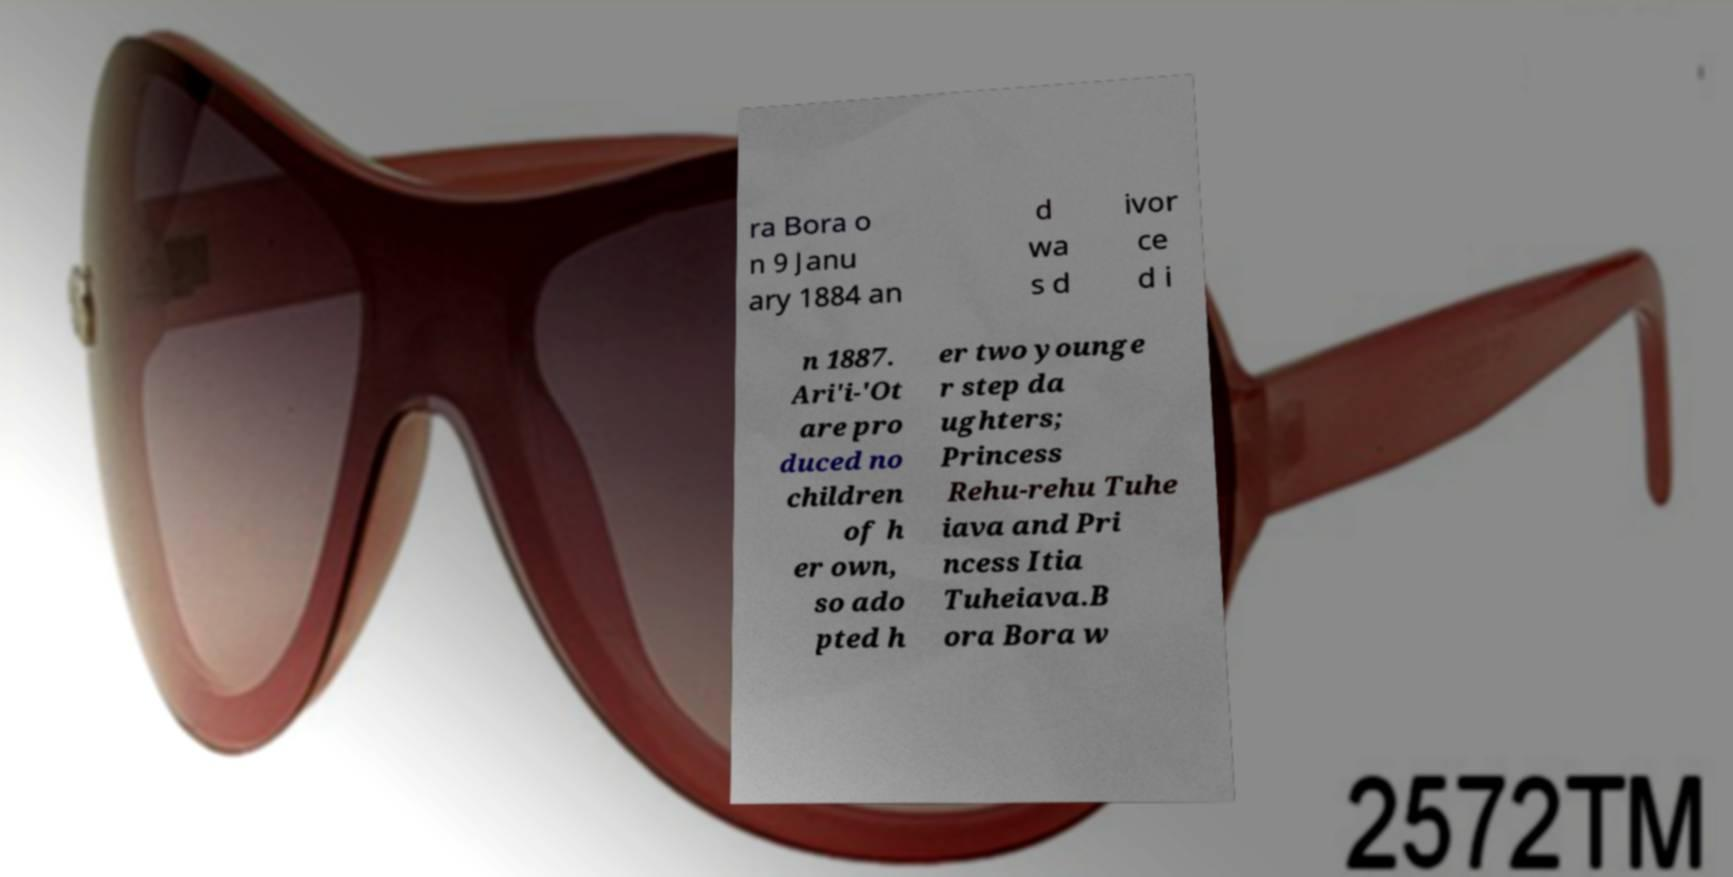What messages or text are displayed in this image? I need them in a readable, typed format. ra Bora o n 9 Janu ary 1884 an d wa s d ivor ce d i n 1887. Ari'i-'Ot are pro duced no children of h er own, so ado pted h er two younge r step da ughters; Princess Rehu-rehu Tuhe iava and Pri ncess Itia Tuheiava.B ora Bora w 